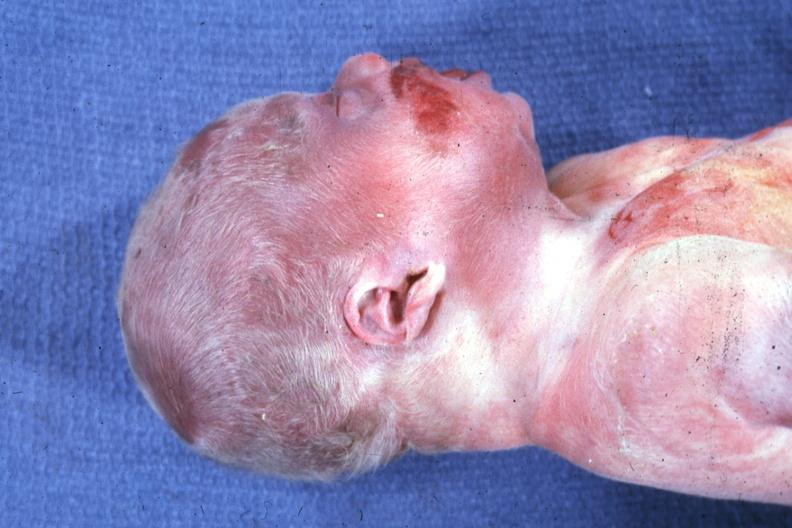what are lateral view of head with ear lobe crease and web neck other photos in file whole body showing diastasis recti and kidneys with bilateral pelvic-ureteral strictures?
Answer the question using a single word or phrase. Anterior face 